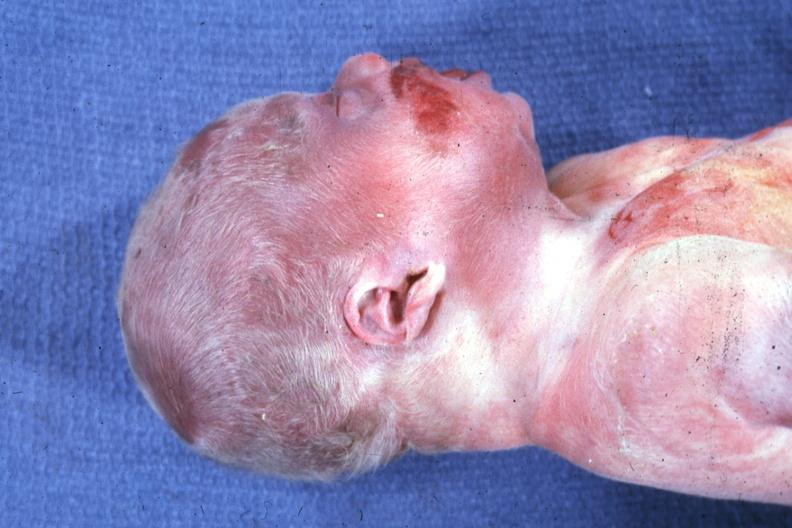what are lateral view of head with ear lobe crease and web neck other photos in file whole body showing diastasis recti and kidneys with bilateral pelvic-ureteral strictures?
Answer the question using a single word or phrase. Anterior face 